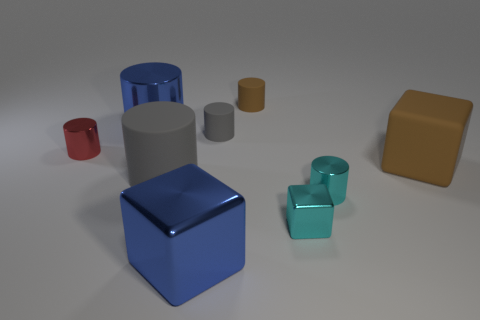There is another large metallic thing that is the same shape as the big gray object; what is its color?
Your response must be concise. Blue. What is the color of the cube that is to the right of the tiny cyan object behind the tiny block?
Keep it short and to the point. Brown. What is the size of the blue thing that is the same shape as the red metallic object?
Your answer should be compact. Large. How many small gray objects are made of the same material as the big brown thing?
Your answer should be very brief. 1. What number of large blue objects are behind the tiny metallic cylinder that is to the left of the big gray rubber object?
Make the answer very short. 1. Are there any metallic cylinders right of the large gray thing?
Ensure brevity in your answer.  Yes. There is a blue thing in front of the large gray rubber object; is its shape the same as the big gray matte thing?
Give a very brief answer. No. There is a tiny cylinder that is the same color as the large matte cylinder; what material is it?
Keep it short and to the point. Rubber. What number of metal cylinders are the same color as the tiny metal cube?
Provide a succinct answer. 1. What is the shape of the small shiny object on the left side of the large thing that is behind the red shiny cylinder?
Provide a short and direct response. Cylinder. 